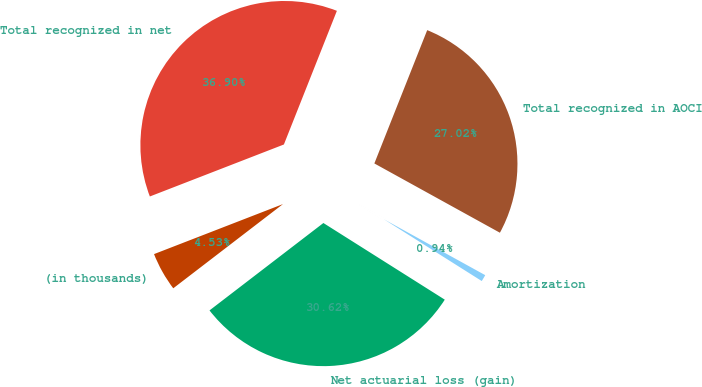Convert chart to OTSL. <chart><loc_0><loc_0><loc_500><loc_500><pie_chart><fcel>(in thousands)<fcel>Net actuarial loss (gain)<fcel>Amortization<fcel>Total recognized in AOCI<fcel>Total recognized in net<nl><fcel>4.53%<fcel>30.62%<fcel>0.94%<fcel>27.02%<fcel>36.9%<nl></chart> 